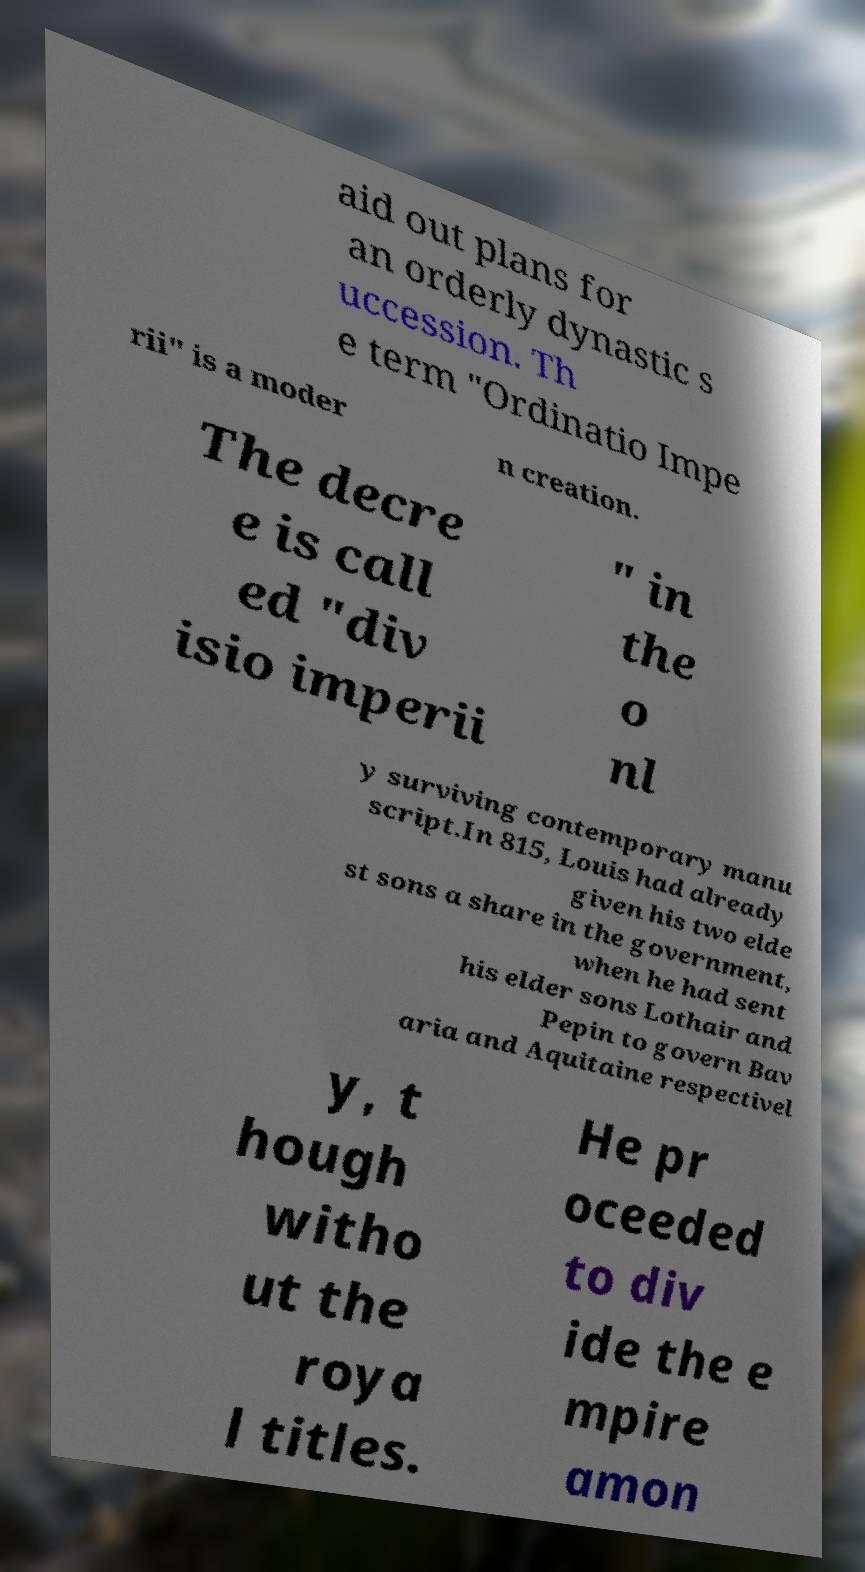I need the written content from this picture converted into text. Can you do that? aid out plans for an orderly dynastic s uccession. Th e term "Ordinatio Impe rii" is a moder n creation. The decre e is call ed "div isio imperii " in the o nl y surviving contemporary manu script.In 815, Louis had already given his two elde st sons a share in the government, when he had sent his elder sons Lothair and Pepin to govern Bav aria and Aquitaine respectivel y, t hough witho ut the roya l titles. He pr oceeded to div ide the e mpire amon 